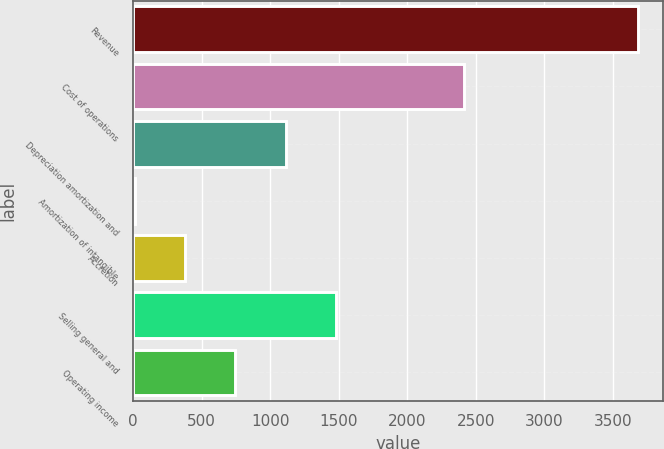Convert chart to OTSL. <chart><loc_0><loc_0><loc_500><loc_500><bar_chart><fcel>Revenue<fcel>Cost of operations<fcel>Depreciation amortization and<fcel>Amortization of intangible<fcel>Accretion<fcel>Selling general and<fcel>Operating income<nl><fcel>3685.1<fcel>2416.7<fcel>1113.79<fcel>11.8<fcel>379.13<fcel>1481.12<fcel>746.46<nl></chart> 